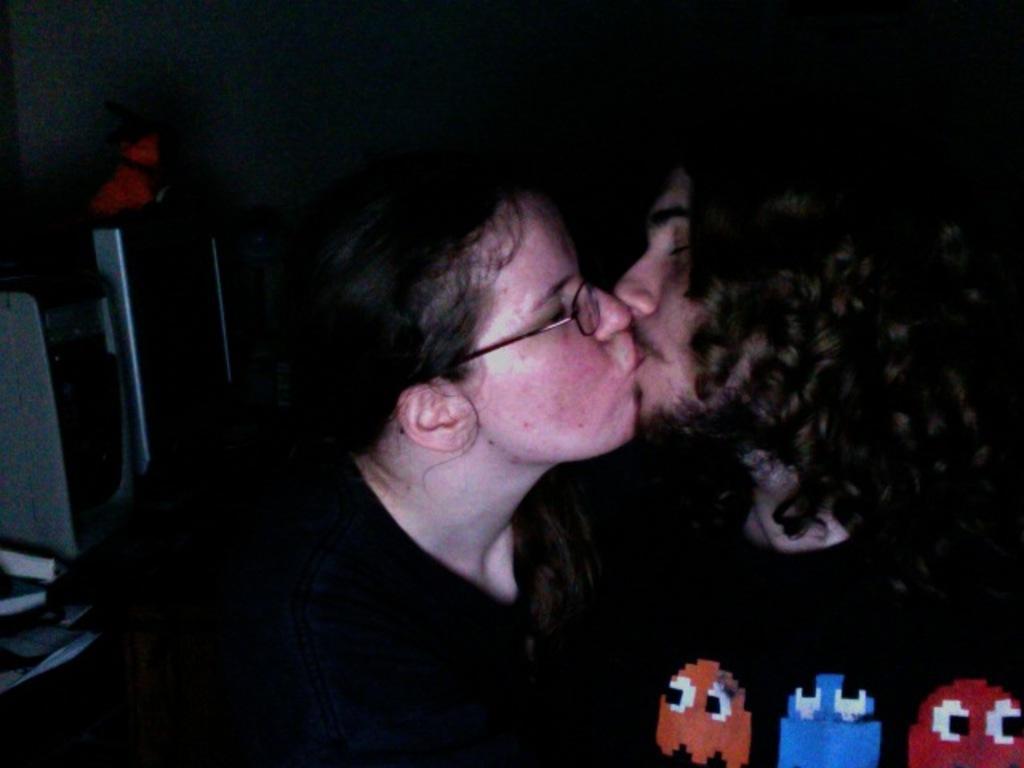In one or two sentences, can you explain what this image depicts? In this image, we can see two persons wearing clothes and kissing each other. There are cartoons in the bottom right of the image. 